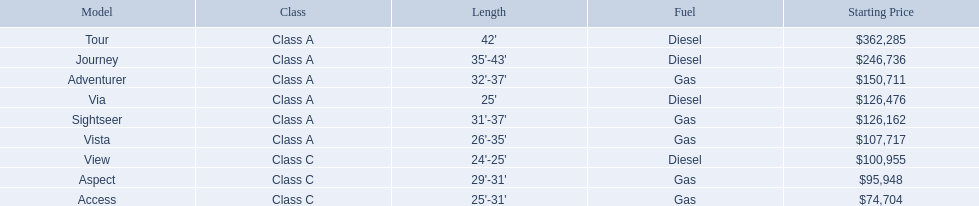What models are made by winnebago industries? Tour, Journey, Adventurer, Via, Sightseer, Vista, View, Aspect, Access. What fuel variety does each model use? Diesel, Diesel, Gas, Diesel, Gas, Gas, Diesel, Gas, Gas. Parse the full table. {'header': ['Model', 'Class', 'Length', 'Fuel', 'Starting Price'], 'rows': [['Tour', 'Class A', "42'", 'Diesel', '$362,285'], ['Journey', 'Class A', "35'-43'", 'Diesel', '$246,736'], ['Adventurer', 'Class A', "32'-37'", 'Gas', '$150,711'], ['Via', 'Class A', "25'", 'Diesel', '$126,476'], ['Sightseer', 'Class A', "31'-37'", 'Gas', '$126,162'], ['Vista', 'Class A', "26'-35'", 'Gas', '$107,717'], ['View', 'Class C', "24'-25'", 'Diesel', '$100,955'], ['Aspect', 'Class C', "29'-31'", 'Gas', '$95,948'], ['Access', 'Class C', "25'-31'", 'Gas', '$74,704']]} And among the tour and aspect, which one functions on diesel? Tour. 